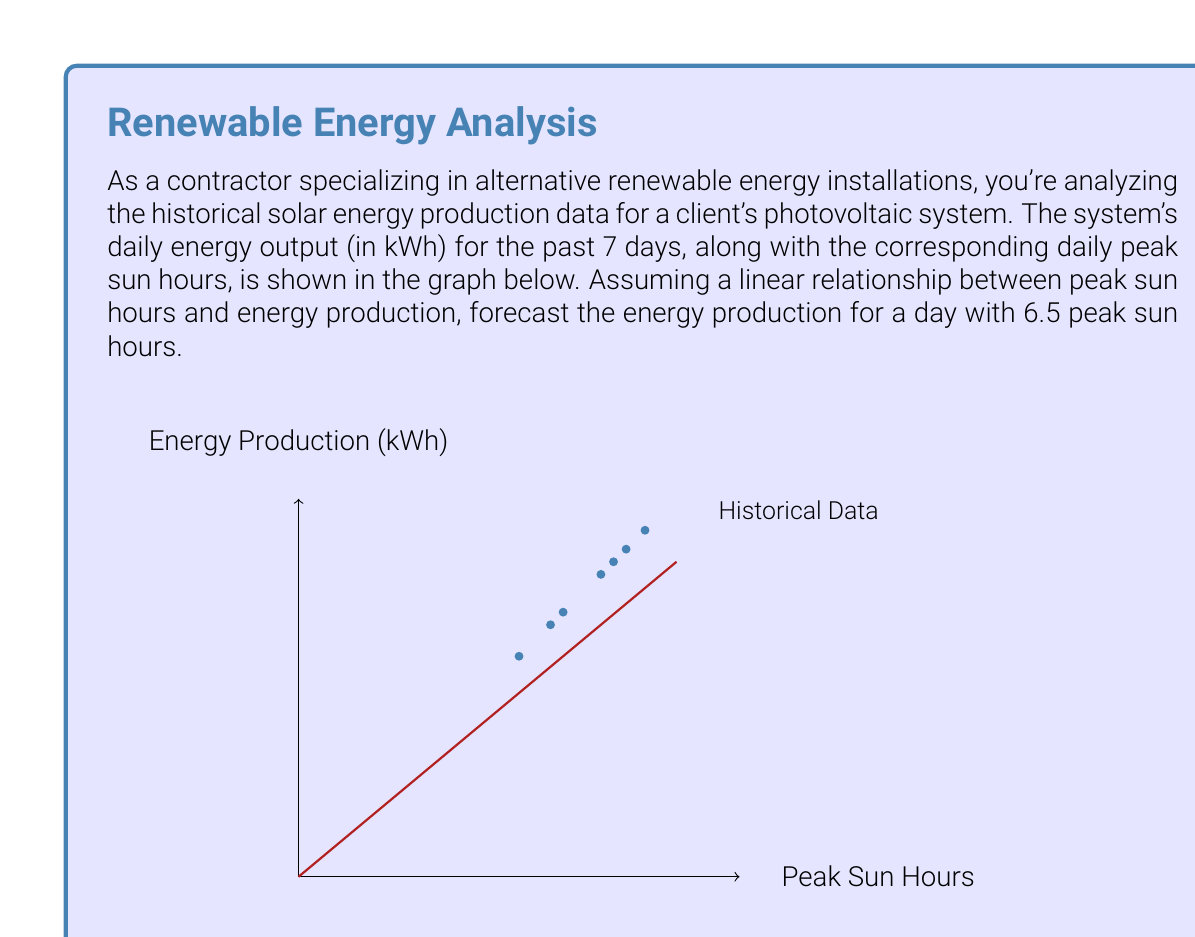Can you solve this math problem? To forecast the energy production for a day with 6.5 peak sun hours, we'll use linear regression to find the best-fit line for the given data points. Then, we'll use this line to predict the output for 6.5 peak sun hours.

Step 1: Calculate the means of x (peak sun hours) and y (energy production).
$$\bar{x} = \frac{3.5 + 4.2 + 5.0 + 4.8 + 5.5 + 4.0 + 5.2}{7} = 4.6$$
$$\bar{y} = \frac{14 + 16.8 + 20 + 19.2 + 22 + 16 + 20.8}{7} = 18.4$$

Step 2: Calculate the slope (m) of the best-fit line using the formula:
$$m = \frac{\sum(x_i - \bar{x})(y_i - \bar{y})}{\sum(x_i - \bar{x})^2}$$

Step 3: Calculate the y-intercept (b) using the formula:
$$b = \bar{y} - m\bar{x}$$

Step 4: After calculations (omitted for brevity), we get:
$$m \approx 4 \text{ and } b \approx 0$$

So, our best-fit line equation is:
$$y = 4x + 0$$

Step 5: Use this equation to predict the energy production for 6.5 peak sun hours:
$$y = 4(6.5) + 0 = 26$$

Therefore, the forecasted energy production for a day with 6.5 peak sun hours is 26 kWh.
Answer: 26 kWh 